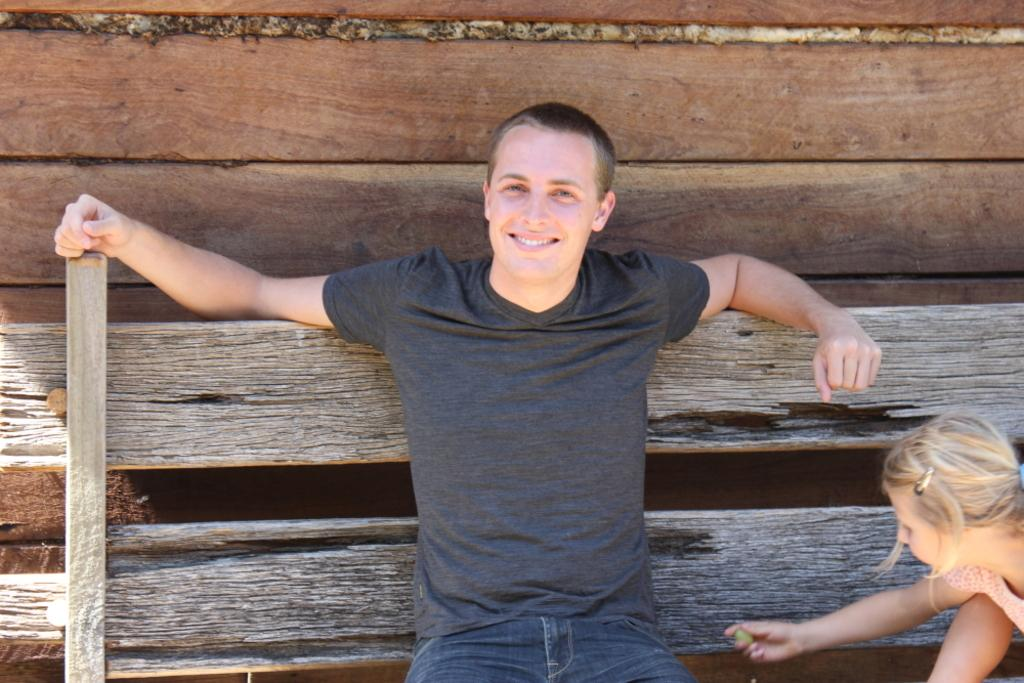What is the person in the image doing? The person is sitting on a wooden bench in the image. What is the girl in the image doing? The girl is playing in the image. What type of advertisement can be seen on the bench in the image? There is no advertisement present on the bench in the image. What is the relation between the person sitting on the bench and the girl playing? The provided facts do not give any information about the relationship between the person and the girl, so we cannot determine their relationship from the image. 